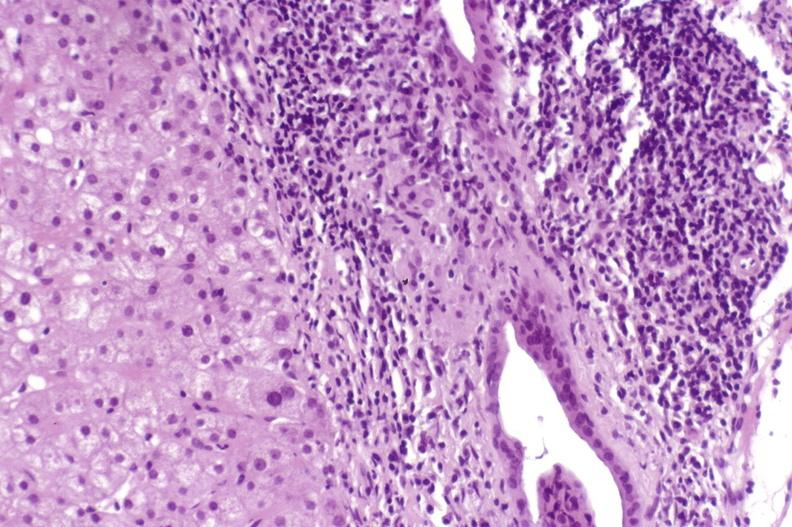s liver present?
Answer the question using a single word or phrase. Yes 